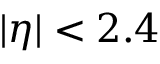Convert formula to latex. <formula><loc_0><loc_0><loc_500><loc_500>| \eta | < 2 . 4</formula> 